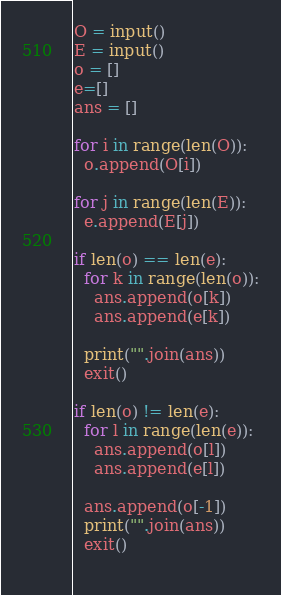Convert code to text. <code><loc_0><loc_0><loc_500><loc_500><_Python_>O = input()
E = input()
o = []
e=[]
ans = []

for i in range(len(O)):
  o.append(O[i])
  
for j in range(len(E)):
  e.append(E[j])
  
if len(o) == len(e):
  for k in range(len(o)):
    ans.append(o[k])
    ans.append(e[k])
    
  print("".join(ans))
  exit()
  
if len(o) != len(e):
  for l in range(len(e)):
    ans.append(o[l])
    ans.append(e[l])
    
  ans.append(o[-1])
  print("".join(ans))
  exit()
    </code> 